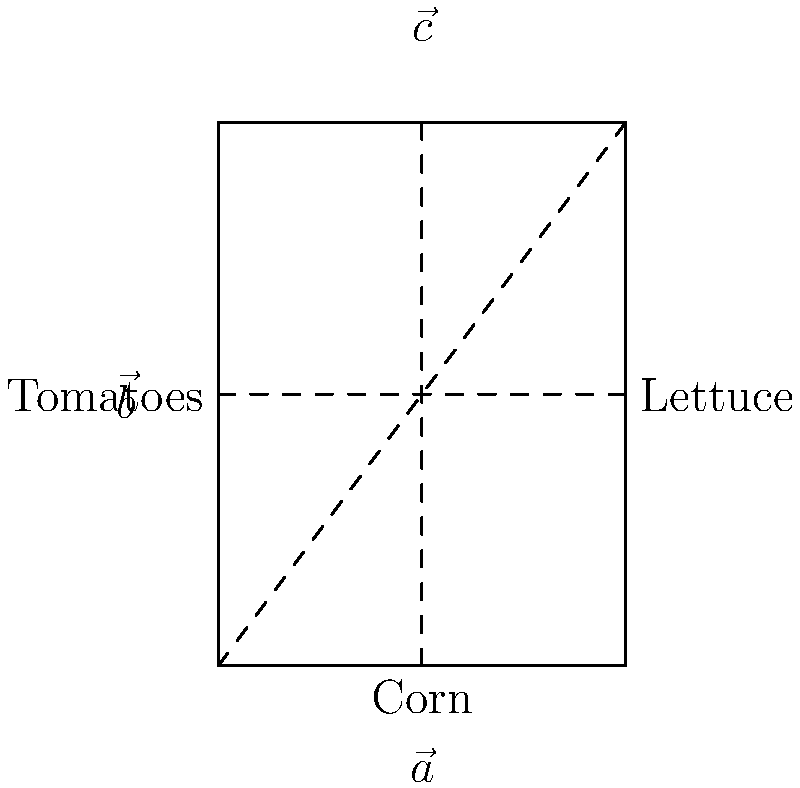You want to optimize the arrangement of crops in a rectangular field. The field is divided into three sections: corn, tomatoes, and lettuce. If $\vec{a}$ represents the vector from the corn to the tomatoes, $\vec{b}$ represents the vector from the tomatoes to the lettuce, and $\vec{c}$ represents the vector from the corn to the lettuce, which vector equation correctly describes the relationship between these crops? Let's approach this step-by-step:

1) First, we need to understand what each vector represents:
   - $\vec{a}$: from corn to tomatoes
   - $\vec{b}$: from tomatoes to lettuce
   - $\vec{c}$: from corn to lettuce

2) Now, let's think about the path these vectors describe:
   - If we start at the corn, go to the tomatoes ($\vec{a}$), and then from the tomatoes to the lettuce ($\vec{b}$), we end up at the same place as if we had gone directly from the corn to the lettuce ($\vec{c}$).

3) In vector addition, this relationship is expressed as:
   $\vec{a} + \vec{b} = \vec{c}$

4) This equation tells us that the sum of the vectors from corn to tomatoes and from tomatoes to lettuce is equal to the vector directly from corn to lettuce.

5) This concept is known as the "triangle law of vector addition" because these vectors form a triangle in the field.

Therefore, the correct vector equation describing the relationship between these crops is $\vec{a} + \vec{b} = \vec{c}$.
Answer: $\vec{a} + \vec{b} = \vec{c}$ 